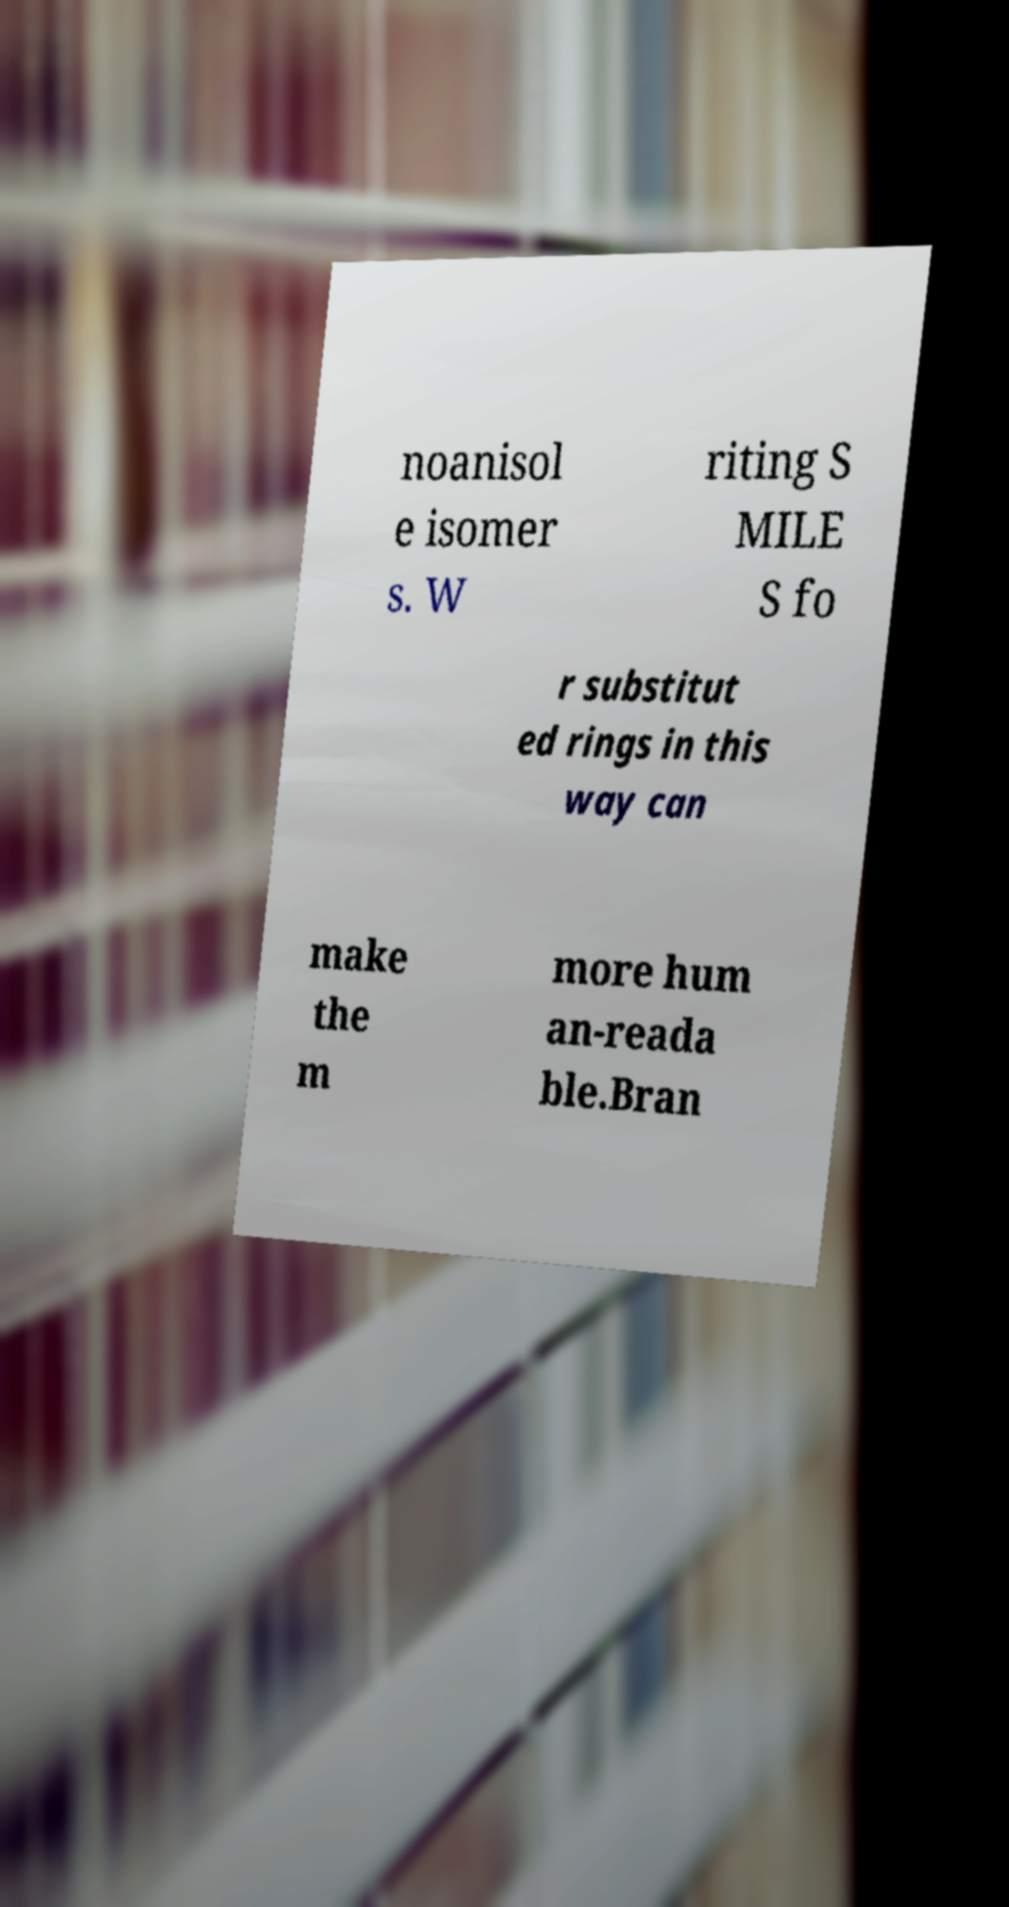Can you accurately transcribe the text from the provided image for me? noanisol e isomer s. W riting S MILE S fo r substitut ed rings in this way can make the m more hum an-reada ble.Bran 